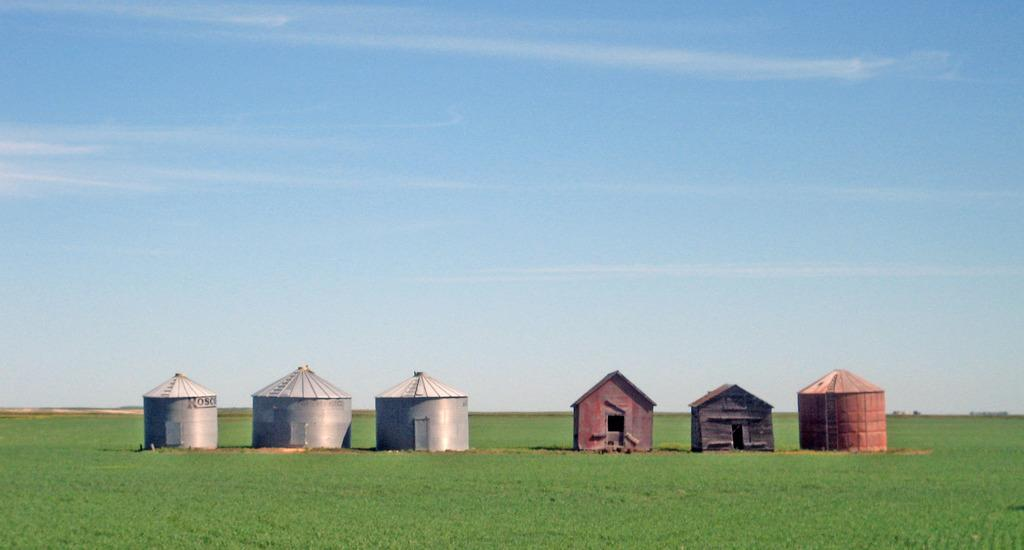How many huts are present in the image? There are six huts in the image. Where are the huts located? The huts are on the grass. What can be seen in the background of the image? The sky is visible in the image. Can you tell me how many horses are grazing near the huts in the image? There is no horse present in the image; it only features six huts on the grass with the sky visible in the background. 